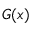<formula> <loc_0><loc_0><loc_500><loc_500>G ( x )</formula> 